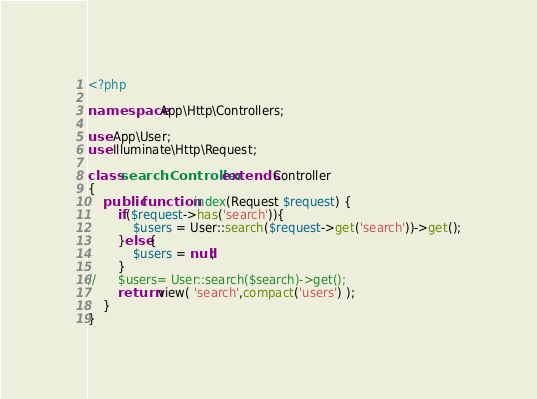Convert code to text. <code><loc_0><loc_0><loc_500><loc_500><_PHP_><?php

namespace App\Http\Controllers;

use App\User;
use Illuminate\Http\Request;

class searchController extends Controller
{
	public function index(Request $request) {
		if($request->has('search')){
			$users = User::search($request->get('search'))->get();
		}else{
			$users = null;
		}
//		$users= User::search($search)->get();
		return view( 'search',compact('users') );
	}
}
</code> 